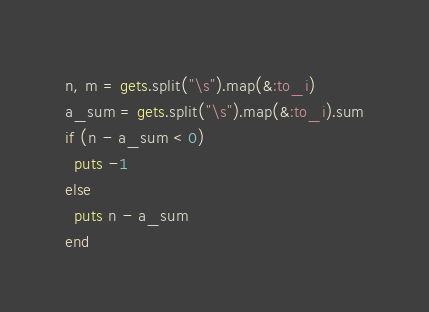<code> <loc_0><loc_0><loc_500><loc_500><_Ruby_>n, m = gets.split("\s").map(&:to_i)
a_sum = gets.split("\s").map(&:to_i).sum
if (n - a_sum < 0) 
  puts -1
else
  puts n - a_sum
end</code> 